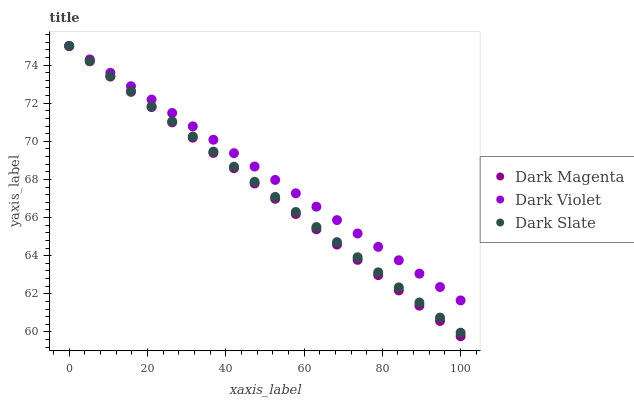Does Dark Magenta have the minimum area under the curve?
Answer yes or no. Yes. Does Dark Violet have the maximum area under the curve?
Answer yes or no. Yes. Does Dark Violet have the minimum area under the curve?
Answer yes or no. No. Does Dark Magenta have the maximum area under the curve?
Answer yes or no. No. Is Dark Magenta the smoothest?
Answer yes or no. Yes. Is Dark Violet the roughest?
Answer yes or no. Yes. Is Dark Violet the smoothest?
Answer yes or no. No. Is Dark Magenta the roughest?
Answer yes or no. No. Does Dark Magenta have the lowest value?
Answer yes or no. Yes. Does Dark Violet have the lowest value?
Answer yes or no. No. Does Dark Violet have the highest value?
Answer yes or no. Yes. Does Dark Magenta intersect Dark Slate?
Answer yes or no. Yes. Is Dark Magenta less than Dark Slate?
Answer yes or no. No. Is Dark Magenta greater than Dark Slate?
Answer yes or no. No. 